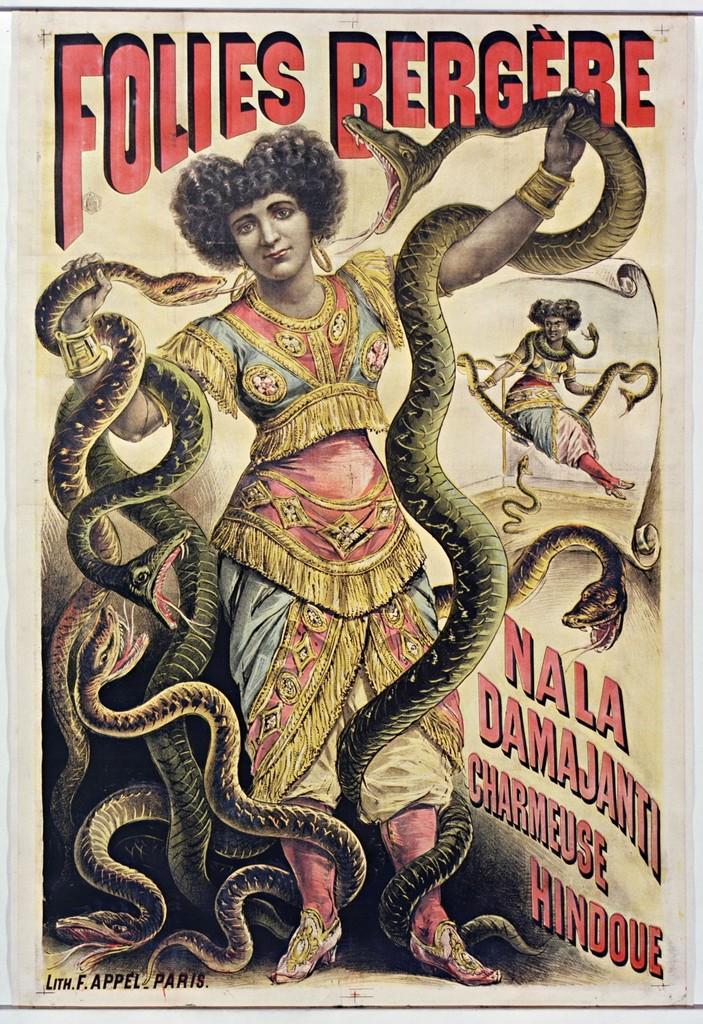Please provide a concise description of this image. This image looks like a poster, in which I can see two persons are holding snakes in their hand and I can see a text. 